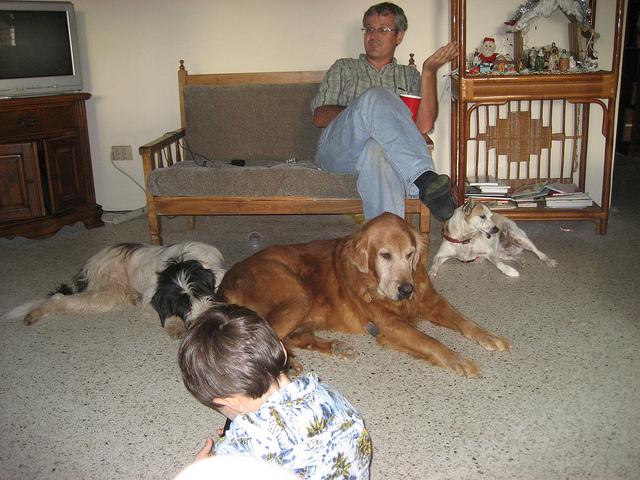Is someone on the couch?
Concise answer only. Yes. How many dogs are relaxing?
Concise answer only. 3. How many dogs are in the photo?
Give a very brief answer. 3. What color is the man?
Answer briefly. White. How many different animals are in the picture?
Keep it brief. 3. Is the dog laying on a deck?
Write a very short answer. No. 